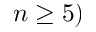Convert formula to latex. <formula><loc_0><loc_0><loc_500><loc_500>n \geq 5 )</formula> 